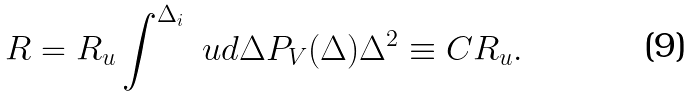<formula> <loc_0><loc_0><loc_500><loc_500>R = R _ { u } \int ^ { \Delta _ { i } } \ u d \Delta P _ { V } ( \Delta ) \Delta ^ { 2 } \equiv C R _ { u } .</formula> 